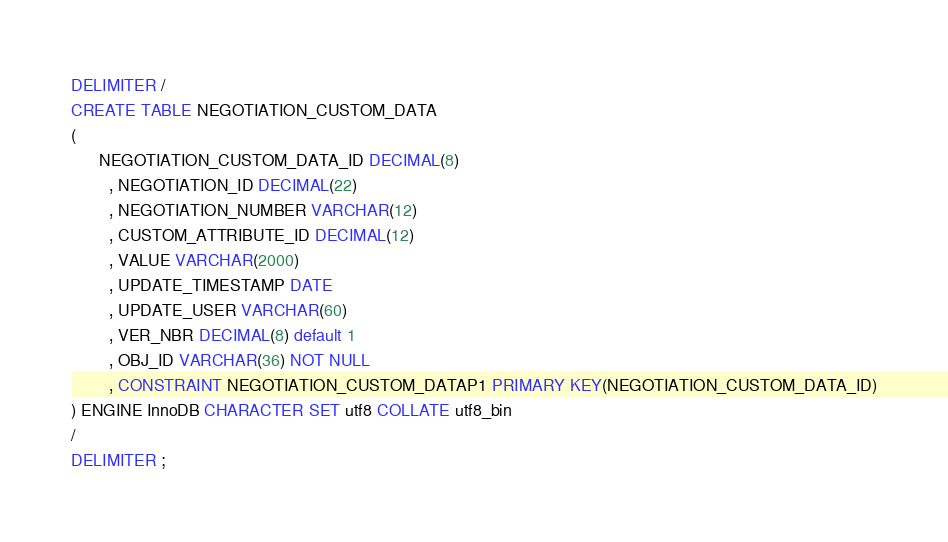<code> <loc_0><loc_0><loc_500><loc_500><_SQL_>DELIMITER /
CREATE TABLE NEGOTIATION_CUSTOM_DATA
(
      NEGOTIATION_CUSTOM_DATA_ID DECIMAL(8)
        , NEGOTIATION_ID DECIMAL(22)
        , NEGOTIATION_NUMBER VARCHAR(12)
        , CUSTOM_ATTRIBUTE_ID DECIMAL(12)
        , VALUE VARCHAR(2000)
        , UPDATE_TIMESTAMP DATE
        , UPDATE_USER VARCHAR(60)
        , VER_NBR DECIMAL(8) default 1
        , OBJ_ID VARCHAR(36) NOT NULL    
        , CONSTRAINT NEGOTIATION_CUSTOM_DATAP1 PRIMARY KEY(NEGOTIATION_CUSTOM_DATA_ID)
) ENGINE InnoDB CHARACTER SET utf8 COLLATE utf8_bin
/
DELIMITER ;
</code> 